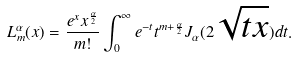Convert formula to latex. <formula><loc_0><loc_0><loc_500><loc_500>L _ { m } ^ { \alpha } ( x ) = \frac { e ^ { x } x ^ { \frac { \alpha } { 2 } } } { m ! } \int _ { 0 } ^ { \infty } e ^ { - t } t ^ { m + \frac { \alpha } { 2 } } J _ { \alpha } ( 2 \sqrt { t x } ) d t .</formula> 